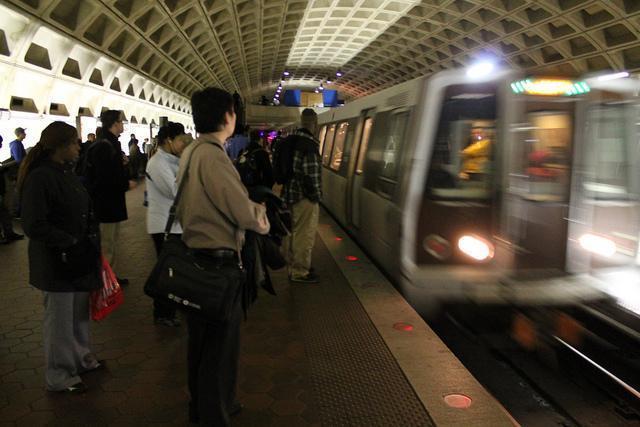How many people are visible?
Give a very brief answer. 5. How many trains can be seen?
Give a very brief answer. 2. 